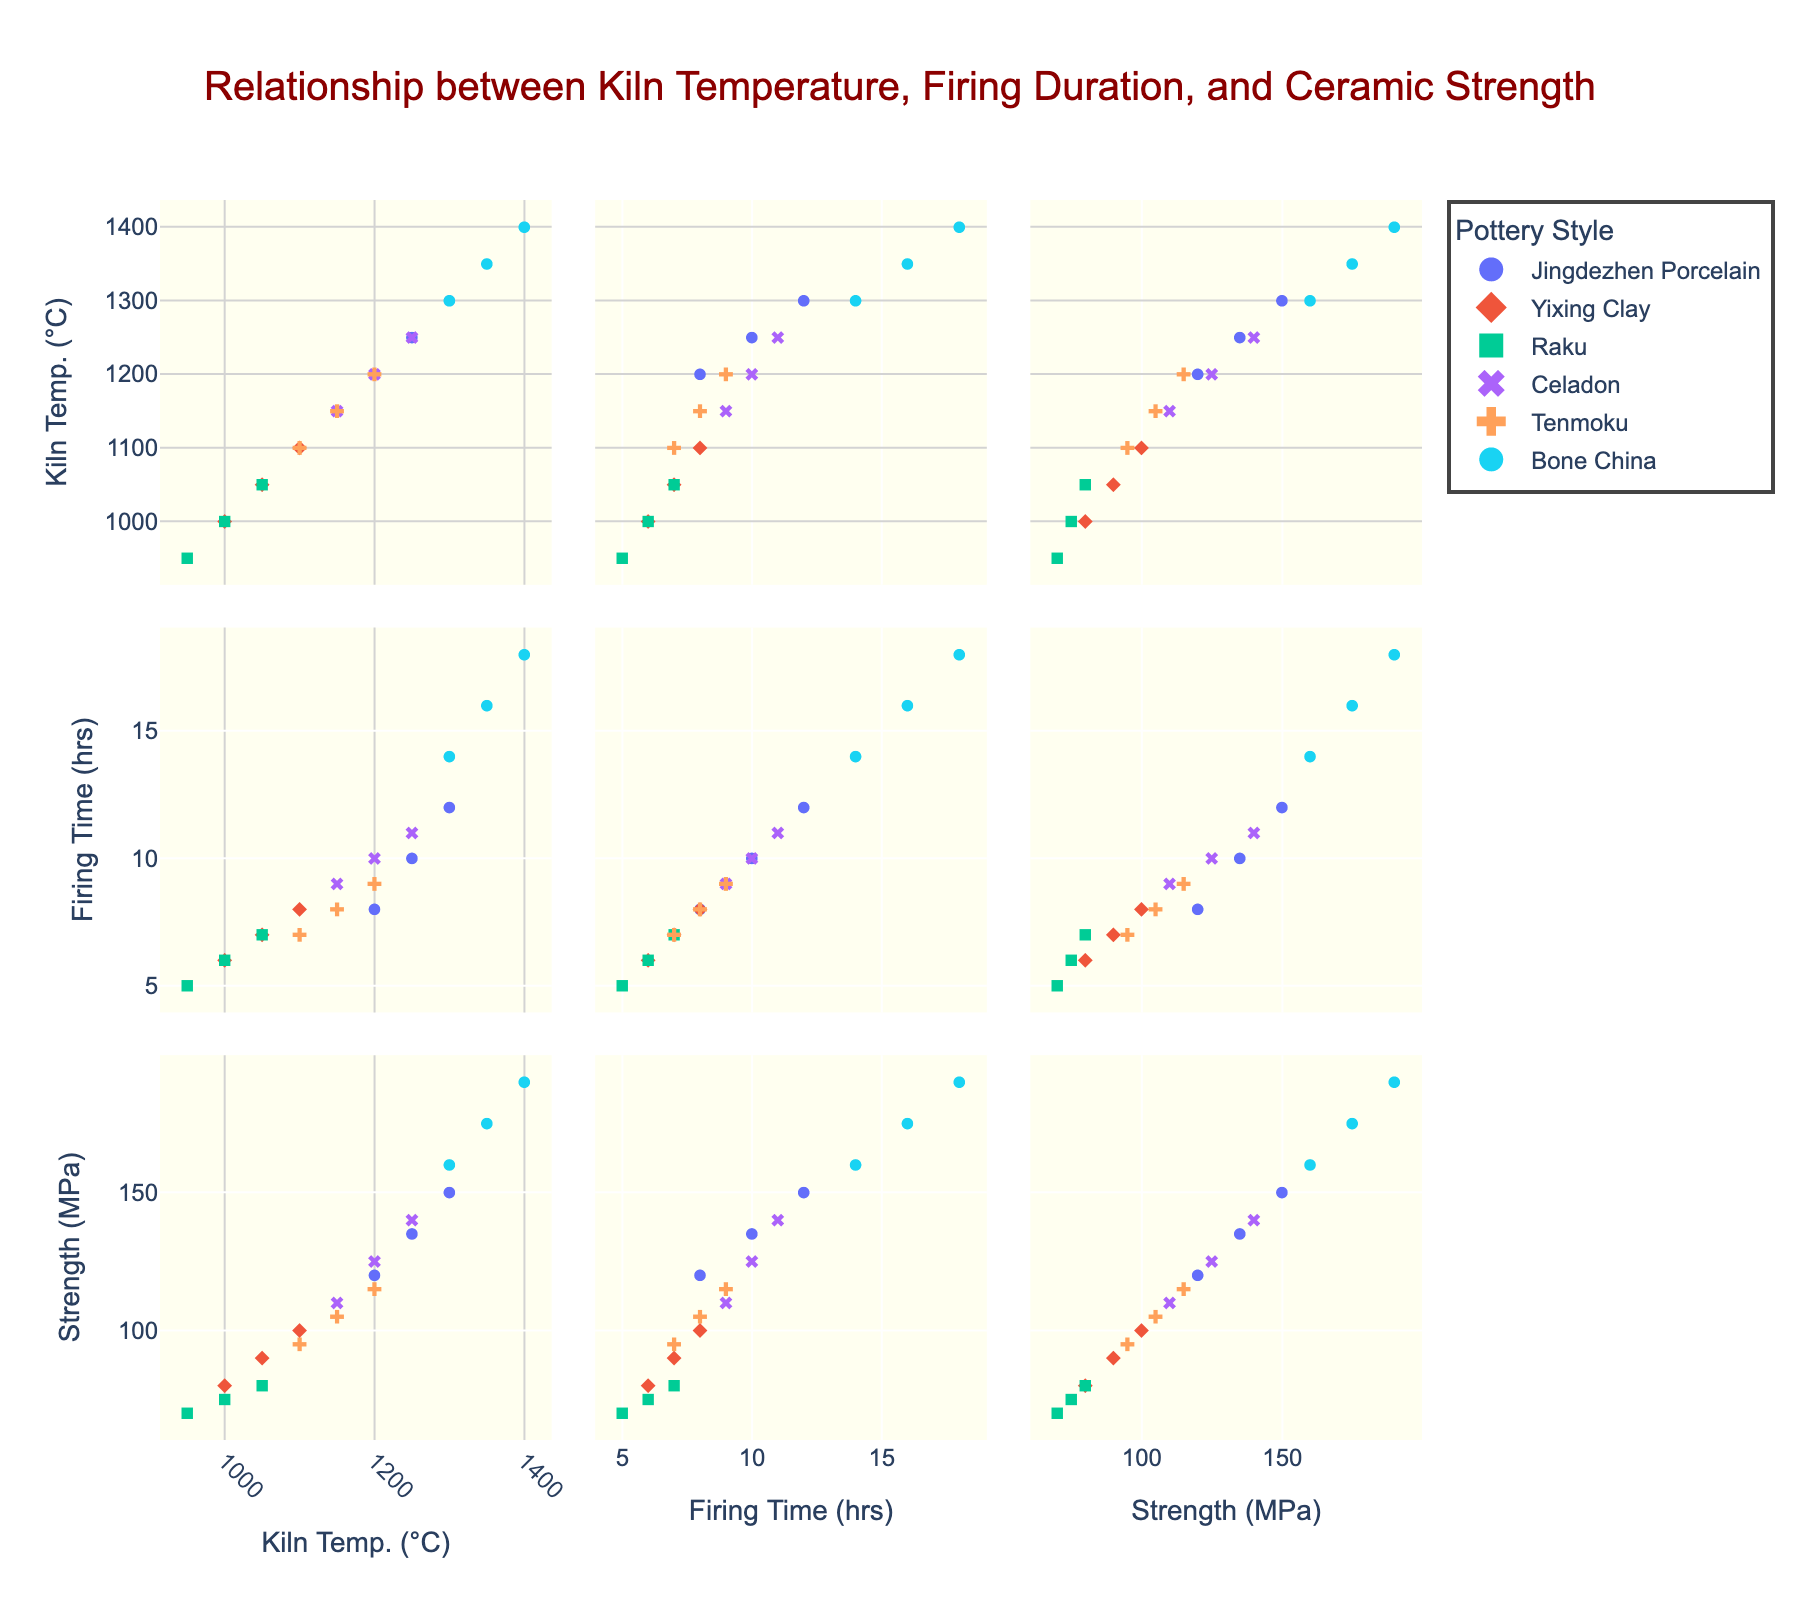What is the title of the figure? The title of the figure is displayed at the top of the scatterplot matrix.
Answer: Relationship between Kiln Temperature, Firing Duration, and Ceramic Strength How many dimensions are represented in the scatterplot matrix? The scatterplot matrix visually represents three dimensions, which can be identified from the axis labels.
Answer: 3 Which pottery style extends to the highest kiln temperature? By examining the scatter points along the Kiln Temperature (°C) axis, it’s clear that Bone China extends to the highest temperature.
Answer: Bone China What is the ceramic strength of Jingdezhen Porcelain at a firing duration of 10 hours? Locate the Jingdezhen Porcelain data points and find the one where the Firing Duration (hours) is 10. Trace its Ceramic Strength (MPa).
Answer: 135 MPa Which pottery style has the lowest ceramic strength? Look at the data points along the Ceramic Strength (MPa) axis to find the minimum value and identify the associated pottery style, which is Raku.
Answer: Raku What is the average kiln temperature for Yixing Clay? Align the Yixing Clay points along the Kiln Temperature (°C) axis and calculate the average value: (1000 + 1050 + 1100) / 3 = 1050°C.
Answer: 1050°C Which two pottery styles have overlapping kiln temperature ranges but different strengths? Compare kiln temperature ranges across pottery styles. Jingdezhen Porcelain and Celadon overlap but have distinct ceramic strengths.
Answer: Jingdezhen Porcelain and Celadon How does ceramic strength vary with kiln temperature for Bone China? Examine Bone China data points along both the Kiln Temperature (°C) and Ceramic Strength (MPa) axes. Ceramic strength increases as kiln temperature rises.
Answer: Increases Which pottery style has the longest firing duration? Check the firing duration (hours) for each pottery style and identify the longest one, which is Bone China at 18 hours.
Answer: Bone China What is the relationship between firing duration and ceramic strength for Tenmoku? Observe the Tenmoku data points and trace how ceramic strength changes with firing duration. It shows a positive correlation.
Answer: Positive correlation 